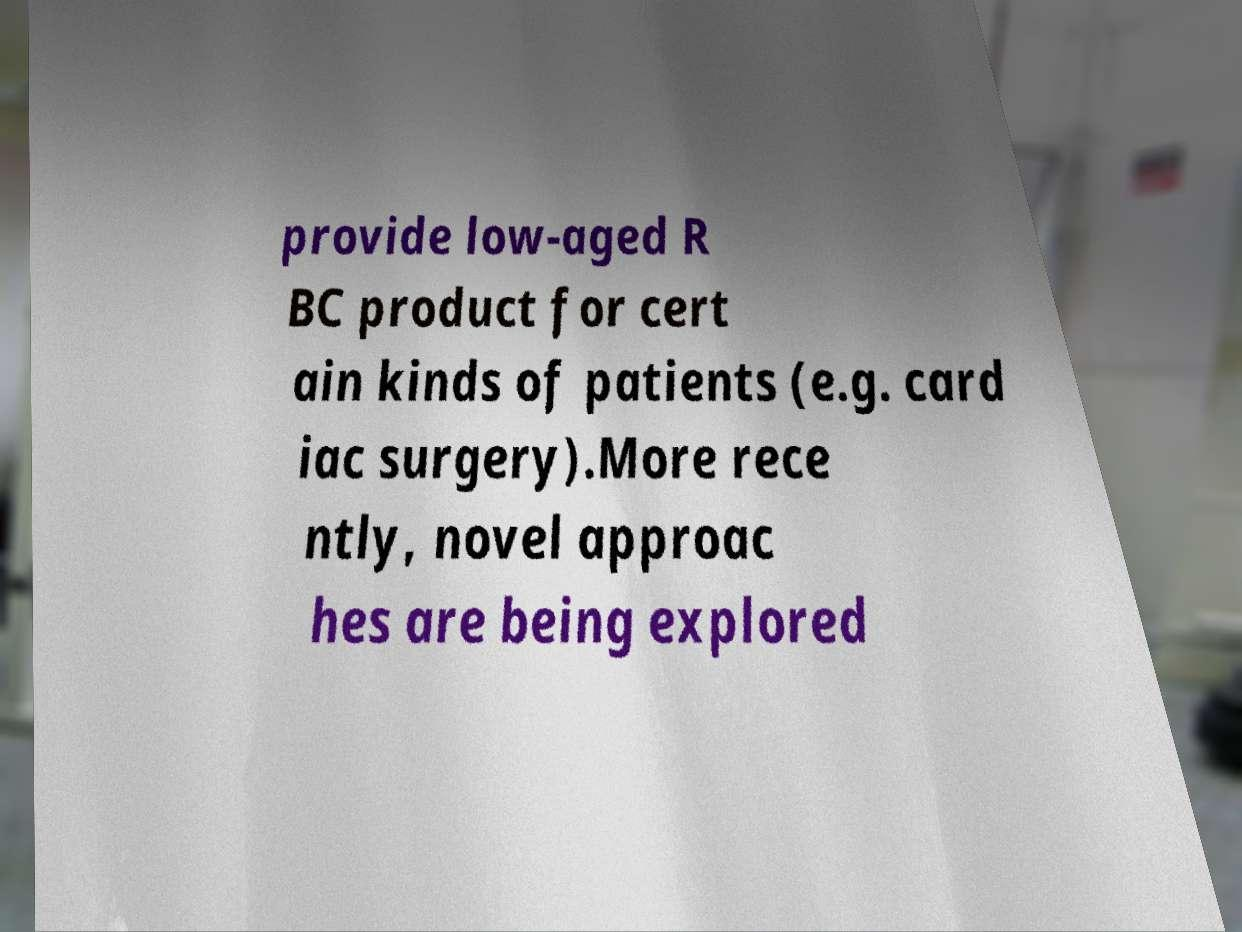Could you assist in decoding the text presented in this image and type it out clearly? provide low-aged R BC product for cert ain kinds of patients (e.g. card iac surgery).More rece ntly, novel approac hes are being explored 